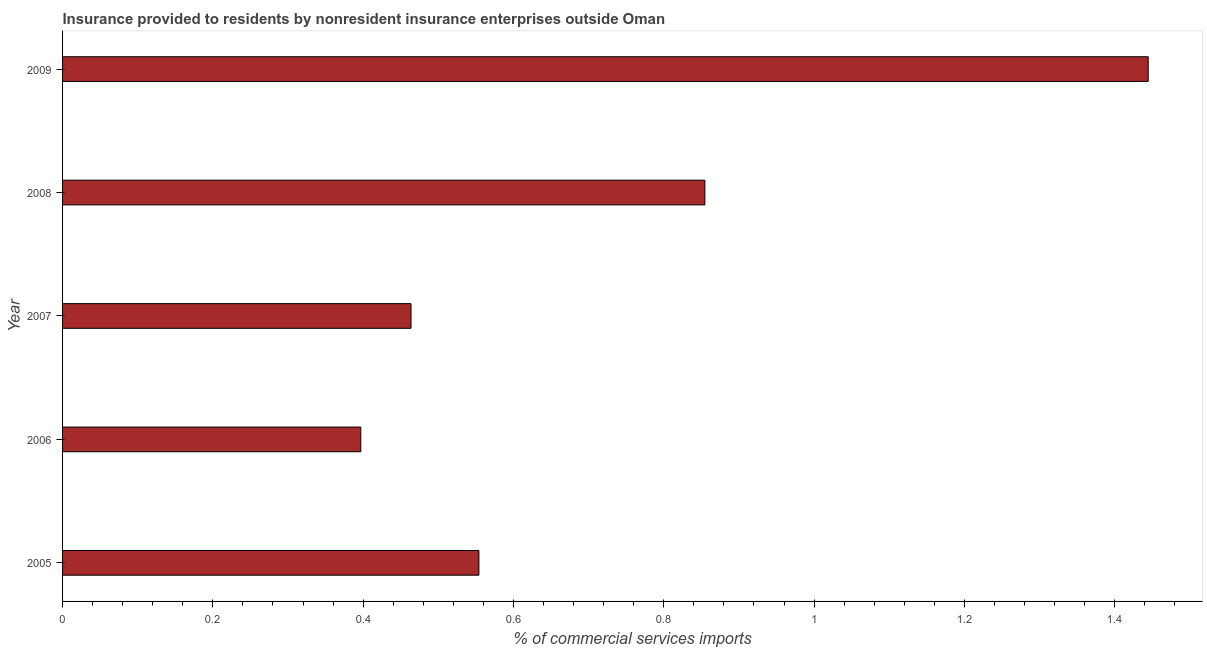Does the graph contain any zero values?
Offer a very short reply. No. What is the title of the graph?
Make the answer very short. Insurance provided to residents by nonresident insurance enterprises outside Oman. What is the label or title of the X-axis?
Provide a short and direct response. % of commercial services imports. What is the insurance provided by non-residents in 2009?
Your response must be concise. 1.44. Across all years, what is the maximum insurance provided by non-residents?
Make the answer very short. 1.44. Across all years, what is the minimum insurance provided by non-residents?
Give a very brief answer. 0.4. What is the sum of the insurance provided by non-residents?
Provide a succinct answer. 3.71. What is the difference between the insurance provided by non-residents in 2008 and 2009?
Your answer should be very brief. -0.59. What is the average insurance provided by non-residents per year?
Offer a very short reply. 0.74. What is the median insurance provided by non-residents?
Make the answer very short. 0.55. What is the ratio of the insurance provided by non-residents in 2007 to that in 2008?
Provide a succinct answer. 0.54. Is the insurance provided by non-residents in 2005 less than that in 2007?
Offer a very short reply. No. Is the difference between the insurance provided by non-residents in 2005 and 2009 greater than the difference between any two years?
Offer a very short reply. No. What is the difference between the highest and the second highest insurance provided by non-residents?
Provide a succinct answer. 0.59. What is the difference between the highest and the lowest insurance provided by non-residents?
Offer a terse response. 1.05. In how many years, is the insurance provided by non-residents greater than the average insurance provided by non-residents taken over all years?
Your response must be concise. 2. How many years are there in the graph?
Make the answer very short. 5. What is the difference between two consecutive major ticks on the X-axis?
Ensure brevity in your answer.  0.2. What is the % of commercial services imports of 2005?
Your answer should be very brief. 0.55. What is the % of commercial services imports in 2006?
Your answer should be very brief. 0.4. What is the % of commercial services imports of 2007?
Your answer should be compact. 0.46. What is the % of commercial services imports of 2008?
Offer a very short reply. 0.85. What is the % of commercial services imports of 2009?
Your answer should be compact. 1.44. What is the difference between the % of commercial services imports in 2005 and 2006?
Give a very brief answer. 0.16. What is the difference between the % of commercial services imports in 2005 and 2007?
Make the answer very short. 0.09. What is the difference between the % of commercial services imports in 2005 and 2008?
Offer a very short reply. -0.3. What is the difference between the % of commercial services imports in 2005 and 2009?
Your response must be concise. -0.89. What is the difference between the % of commercial services imports in 2006 and 2007?
Keep it short and to the point. -0.07. What is the difference between the % of commercial services imports in 2006 and 2008?
Provide a succinct answer. -0.46. What is the difference between the % of commercial services imports in 2006 and 2009?
Give a very brief answer. -1.05. What is the difference between the % of commercial services imports in 2007 and 2008?
Your answer should be very brief. -0.39. What is the difference between the % of commercial services imports in 2007 and 2009?
Make the answer very short. -0.98. What is the difference between the % of commercial services imports in 2008 and 2009?
Make the answer very short. -0.59. What is the ratio of the % of commercial services imports in 2005 to that in 2006?
Give a very brief answer. 1.4. What is the ratio of the % of commercial services imports in 2005 to that in 2007?
Provide a short and direct response. 1.2. What is the ratio of the % of commercial services imports in 2005 to that in 2008?
Make the answer very short. 0.65. What is the ratio of the % of commercial services imports in 2005 to that in 2009?
Your answer should be compact. 0.38. What is the ratio of the % of commercial services imports in 2006 to that in 2007?
Offer a very short reply. 0.86. What is the ratio of the % of commercial services imports in 2006 to that in 2008?
Provide a succinct answer. 0.46. What is the ratio of the % of commercial services imports in 2006 to that in 2009?
Make the answer very short. 0.28. What is the ratio of the % of commercial services imports in 2007 to that in 2008?
Ensure brevity in your answer.  0.54. What is the ratio of the % of commercial services imports in 2007 to that in 2009?
Provide a succinct answer. 0.32. What is the ratio of the % of commercial services imports in 2008 to that in 2009?
Your answer should be very brief. 0.59. 